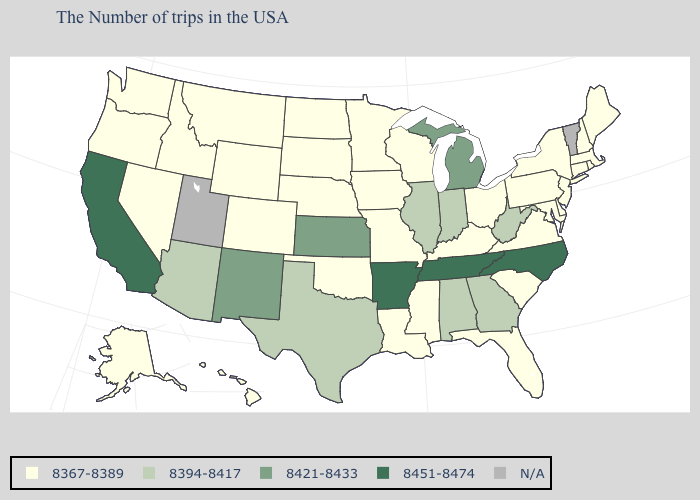Name the states that have a value in the range 8394-8417?
Short answer required. West Virginia, Georgia, Indiana, Alabama, Illinois, Texas, Arizona. Name the states that have a value in the range 8394-8417?
Answer briefly. West Virginia, Georgia, Indiana, Alabama, Illinois, Texas, Arizona. What is the highest value in the USA?
Give a very brief answer. 8451-8474. What is the value of Mississippi?
Keep it brief. 8367-8389. Does the map have missing data?
Quick response, please. Yes. Name the states that have a value in the range 8421-8433?
Write a very short answer. Michigan, Kansas, New Mexico. Does Nebraska have the lowest value in the USA?
Be succinct. Yes. What is the lowest value in the South?
Give a very brief answer. 8367-8389. Does West Virginia have the lowest value in the USA?
Short answer required. No. What is the value of Colorado?
Give a very brief answer. 8367-8389. Does Michigan have the highest value in the USA?
Keep it brief. No. What is the highest value in states that border Maryland?
Write a very short answer. 8394-8417. Among the states that border West Virginia , which have the highest value?
Answer briefly. Maryland, Pennsylvania, Virginia, Ohio, Kentucky. 